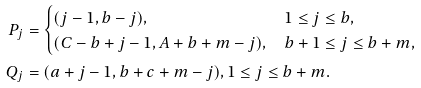<formula> <loc_0><loc_0><loc_500><loc_500>P _ { j } & = \begin{cases} ( j - 1 , b - j ) , & 1 \leq j \leq b , \\ ( C - b + j - 1 , A + b + m - j ) , & b + 1 \leq j \leq b + m , \end{cases} \\ Q _ { j } & = ( a + j - 1 , b + c + m - j ) , 1 \leq j \leq b + m .</formula> 